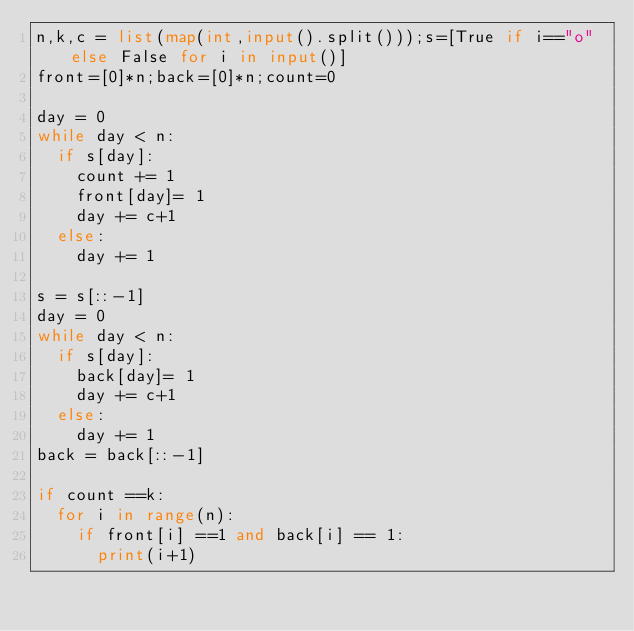Convert code to text. <code><loc_0><loc_0><loc_500><loc_500><_Python_>n,k,c = list(map(int,input().split()));s=[True if i=="o" else False for i in input()]
front=[0]*n;back=[0]*n;count=0

day = 0
while day < n:
  if s[day]:
    count += 1
    front[day]= 1
    day += c+1
  else:
    day += 1
    
s = s[::-1]
day = 0
while day < n:
  if s[day]:
    back[day]= 1
    day += c+1
  else:
    day += 1
back = back[::-1]
    
if count ==k:
  for i in range(n):
    if front[i] ==1 and back[i] == 1:
      print(i+1)</code> 